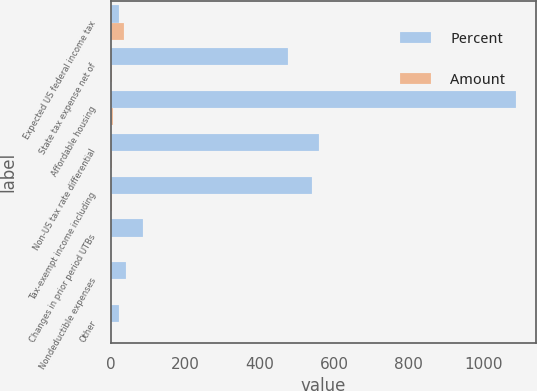Convert chart to OTSL. <chart><loc_0><loc_0><loc_500><loc_500><stacked_bar_chart><ecel><fcel>Expected US federal income tax<fcel>State tax expense net of<fcel>Affordable housing<fcel>Non-US tax rate differential<fcel>Tax-exempt income including<fcel>Changes in prior period UTBs<fcel>Nondeductible expenses<fcel>Other<nl><fcel>Percent<fcel>21<fcel>474<fcel>1087<fcel>559<fcel>539<fcel>85<fcel>40<fcel>21<nl><fcel>Amount<fcel>35<fcel>2.1<fcel>4.9<fcel>2.5<fcel>2.4<fcel>0.4<fcel>0.2<fcel>0.1<nl></chart> 